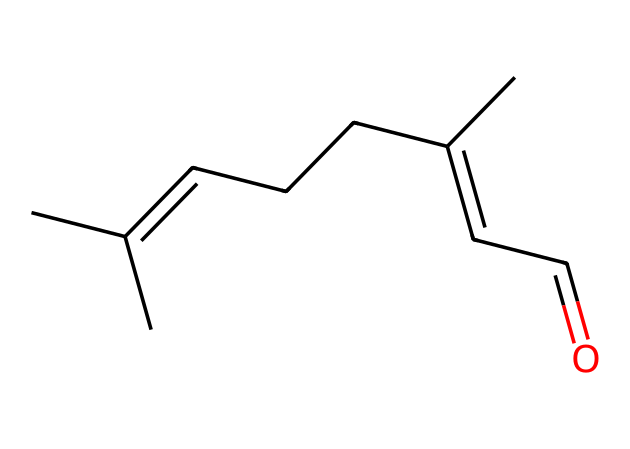How many carbon atoms are in citral? The SMILES representation shows "CC(C)=CCCC(C)=CC=O," which indicates the presence of 10 carbon atoms (C). You can count each "C" in the SMILES to confirm this.
Answer: 10 What functional group is present in citral? The presence of "CC=O" at the end of the SMILES indicates the presence of a carbonyl group (C=O), which is characteristic of aldehydes.
Answer: carbonyl What is the total number of double bonds in citral? The SMILES shows that there are two double bonds: one in the carbon chain and one in the carbonyl group (C=O). Counting these gives us the total.
Answer: 2 Is citral a saturated or unsaturated compound? Since the SMILES contains double bonds, specifically in the carbon chain (C=C), this indicates that citral is an unsaturated compound.
Answer: unsaturated What type of aldehyde is citral considered? Given that citral has a long hydrocarbon chain with the carbonyl group at one end, it is classified as a "linear" or "aliphatic" aldehyde.
Answer: aliphatic 